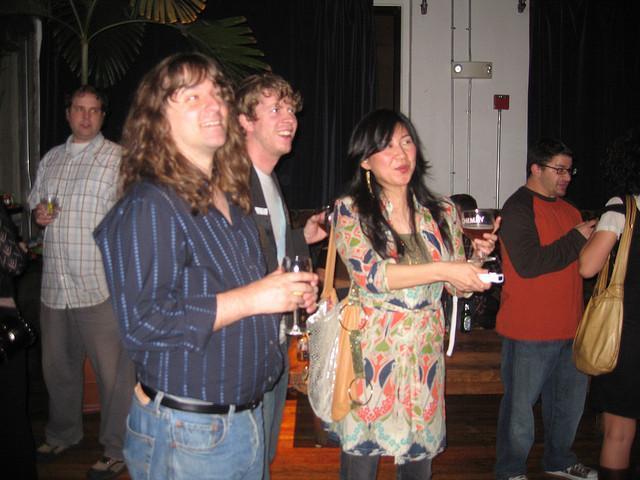How many women can you see in the picture?
Give a very brief answer. 2. How many people are in the image?
Give a very brief answer. 6. How many handbags are in the photo?
Give a very brief answer. 2. How many people can you see?
Give a very brief answer. 7. 